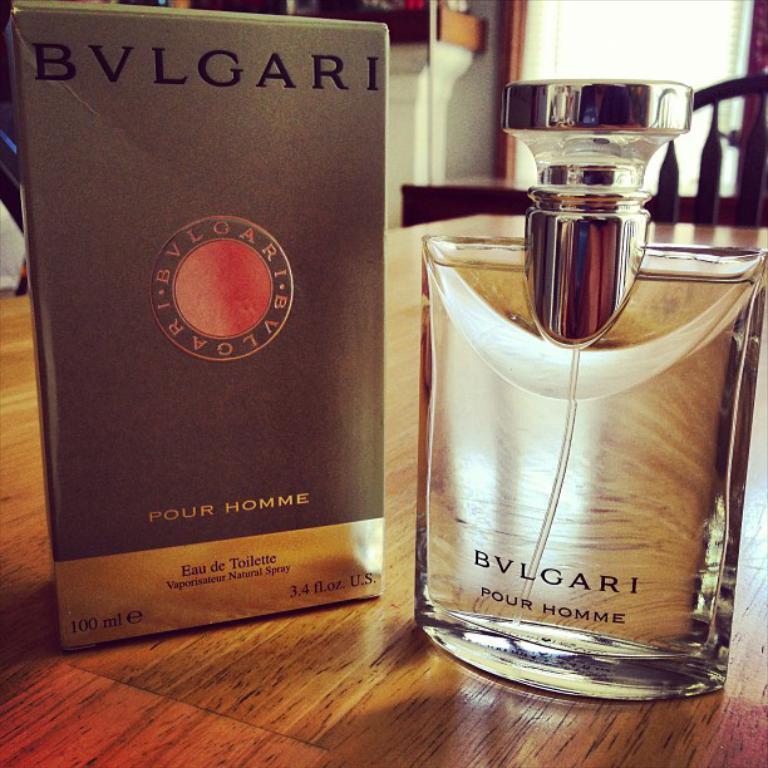Could you give a brief overview of what you see in this image? In the foreground of the picture I can see an alcohol bottle and bottle box are kept on the wooden table. It is looking like a wooden chair on the top right side. In the background, I can see the glass window. 